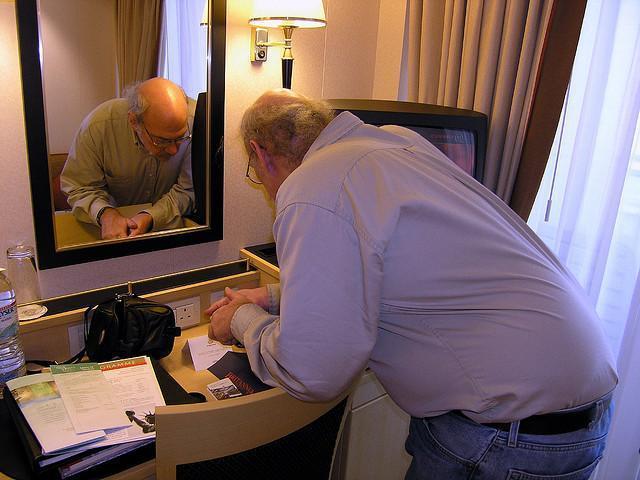How many people are visible?
Give a very brief answer. 2. 